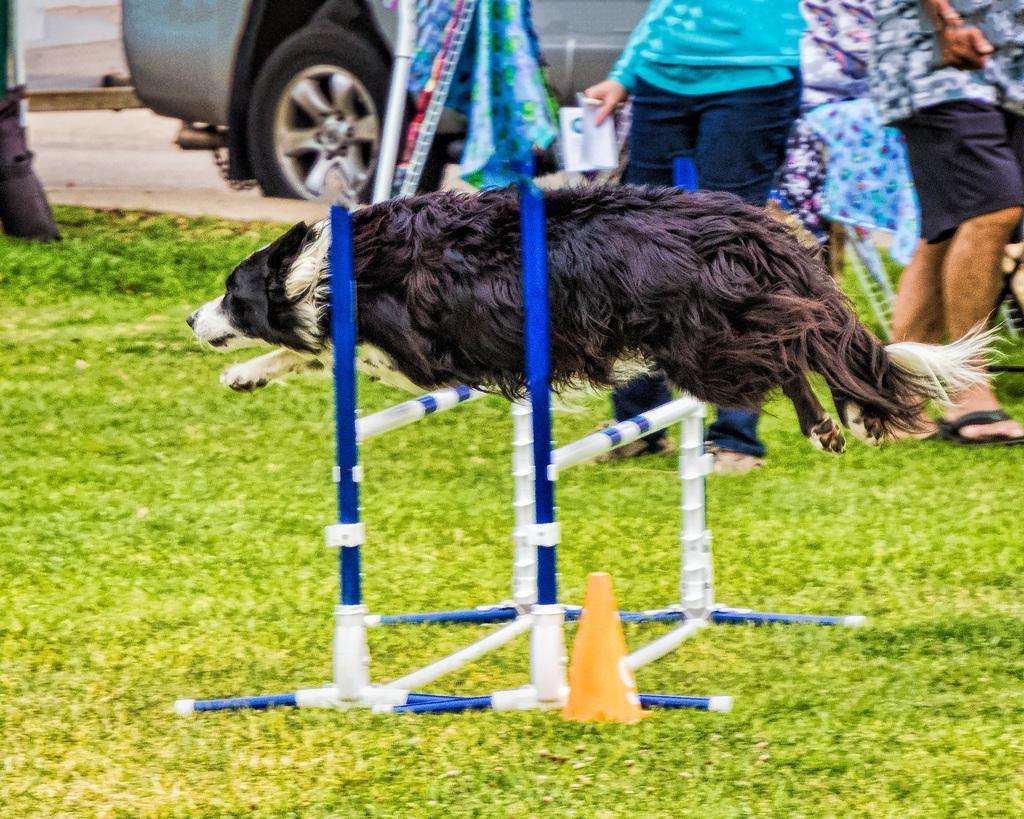Could you give a brief overview of what you see in this image? This picture is clicked outside. In the center we can see a dog seems to be jumping in the air and we can see the metal rods and a safety cone is placed on the top of the ground and we can see the group of persons, vehicle, green grass and some other objects. 